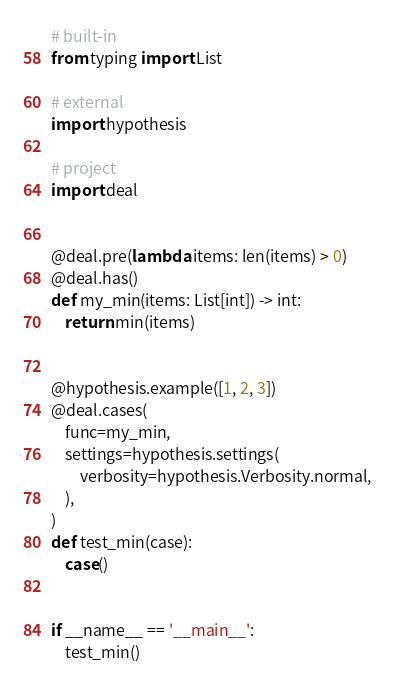Convert code to text. <code><loc_0><loc_0><loc_500><loc_500><_Python_># built-in
from typing import List

# external
import hypothesis

# project
import deal


@deal.pre(lambda items: len(items) > 0)
@deal.has()
def my_min(items: List[int]) -> int:
    return min(items)


@hypothesis.example([1, 2, 3])
@deal.cases(
    func=my_min,
    settings=hypothesis.settings(
        verbosity=hypothesis.Verbosity.normal,
    ),
)
def test_min(case):
    case()


if __name__ == '__main__':
    test_min()
</code> 